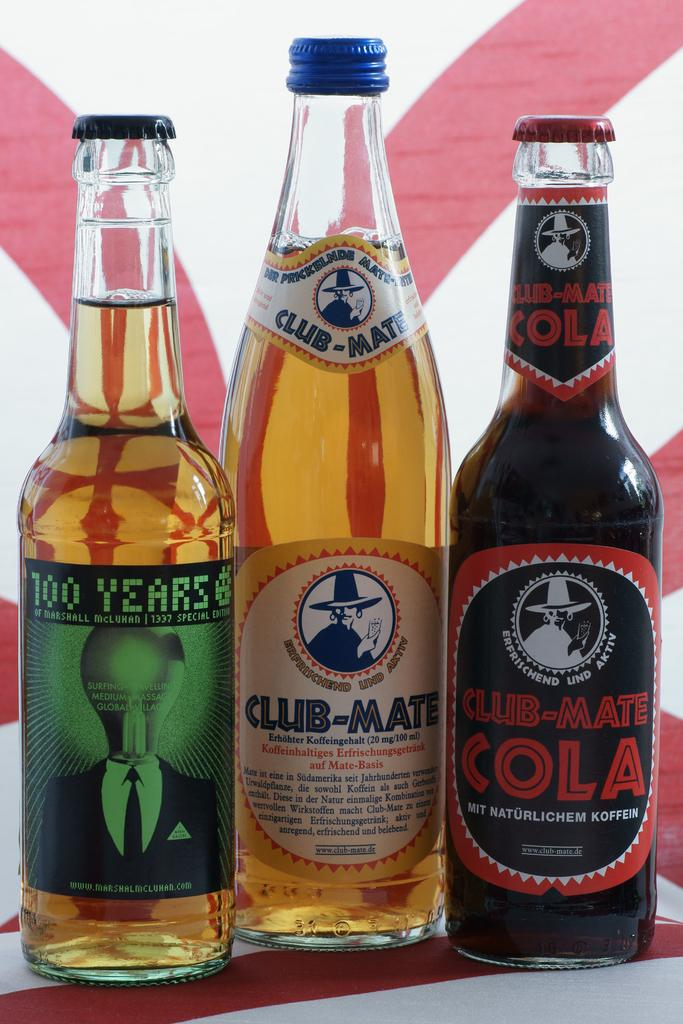Provide a one-sentence caption for the provided image. Three different Club-Mate beverages are in a row. 